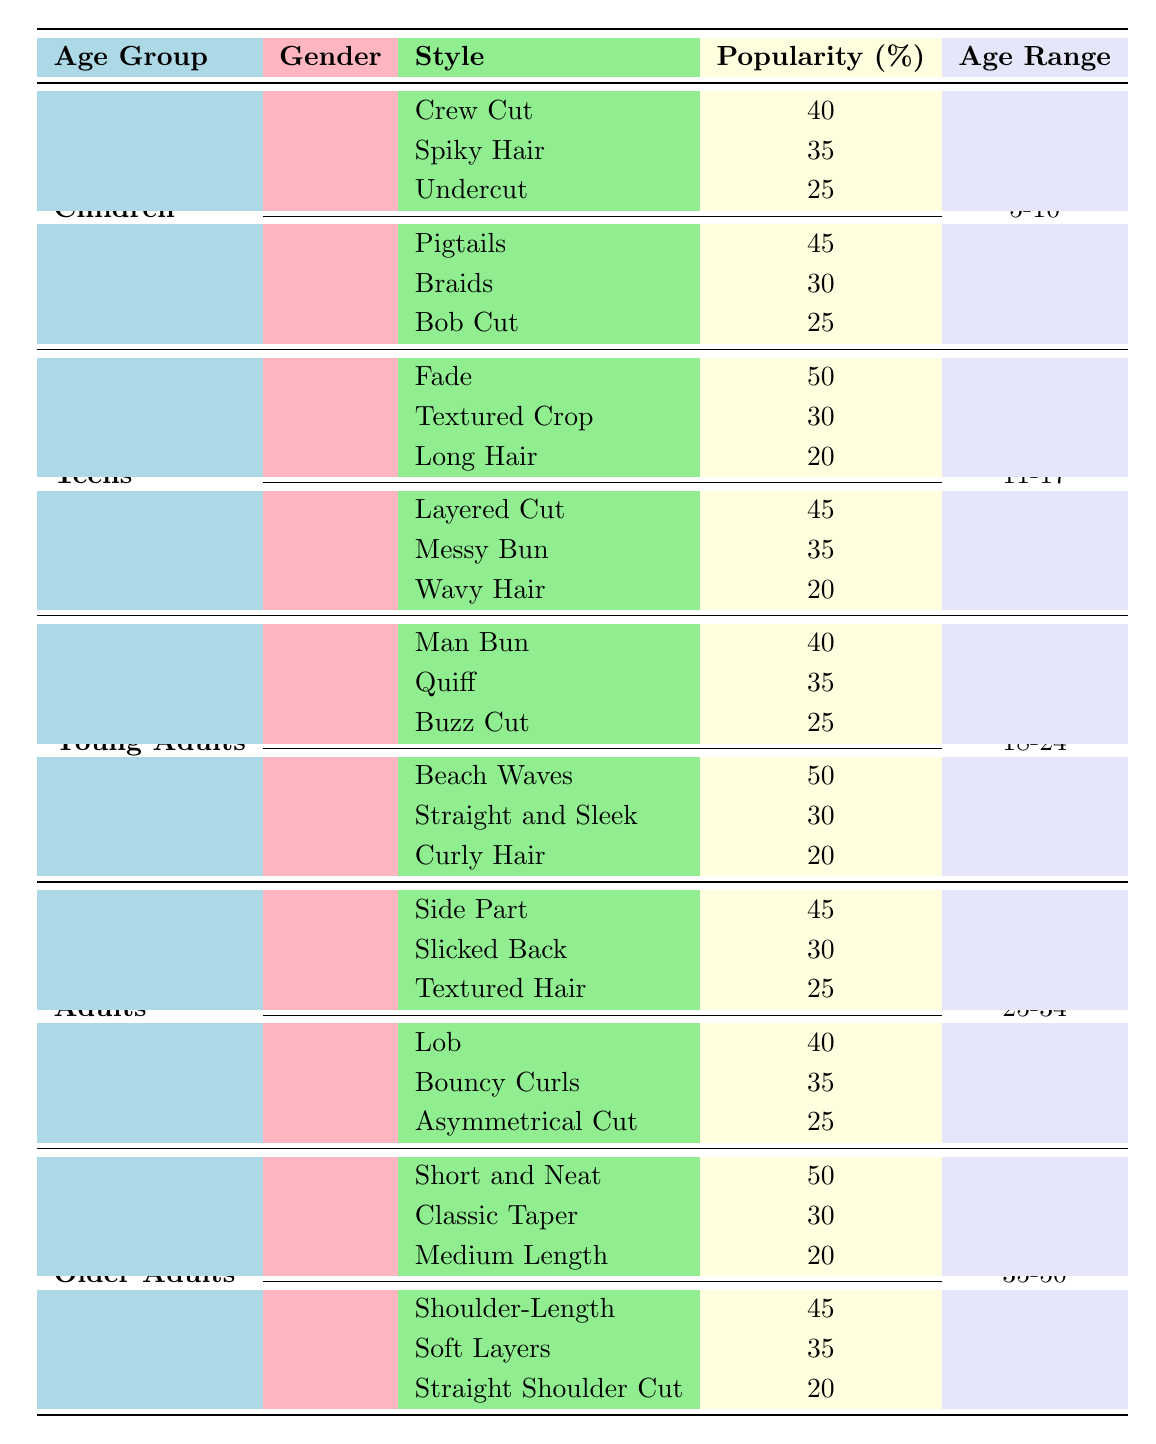What hairstyle is the most popular among boys aged 5-10? The table shows that "Crew Cut" has a popularity of 40%, which is higher than "Spiky Hair" at 35% and "Undercut" at 25%. Therefore, "Crew Cut" is the most popular.
Answer: Crew Cut What is the overall popularity percentage for girls' hairstyles in the teen age group? To find this, we will sum the popularity of all three hairstyles for girls in the teens: Layered Cut (45), Messy Bun (35), and Wavy Hair (20), which gives us 45 + 35 + 20 = 100%.
Answer: 100% Is the popularity of the "Man Bun" hairstyle in young adults higher than the "Short and Neat" hairstyle in older adults? The "Man Bun" has a popularity of 40%, while "Short and Neat" has a popularity of 50%. Since 40% is not higher than 50%, the answer is no.
Answer: No What is the average popularity of boys' hairstyles in the children age group? The popularity percentages for boys’ hairstyles are Crew Cut (40%), Spiky Hair (35%), and Undercut (25%). To find the average, add these values: 40 + 35 + 25 = 100, and divide by the number of hairstyles (3): 100/3 = 33.33%.
Answer: 33.33% Which hairstyle is the least popular for girls aged 11-17? Among the hairstyles for girls aged 11-17, Wavy Hair has the lowest popularity at 20%, compared to Layered Cut (45%) and Messy Bun (35%).
Answer: Wavy Hair What hairstyle do older adult women prefer the most? The table indicates that older adult women prefer "Shoulder-Length" with a popularity of 45%, which is higher than "Soft Layers" at 35% and "Straight Shoulder Cut" at 20%.
Answer: Shoulder-Length Is there a hairstyle popular among both young adult men and women with a popularity of 30%? Checking the popularity data, the "Quiff" for young adult men is at 35%, and "Straight and Sleek" for young adult women is also 30%. Since only "Straight and Sleek" has exactly 30%, the answer is yes for women but no for a matching style in men.
Answer: Yes (only for women) What hairstyle received 50% popularity among teens boys? The table specifies that "Fade" has a popularity of 50% among teen boys, which is the only style listed in that category with that percentage.
Answer: Fade 